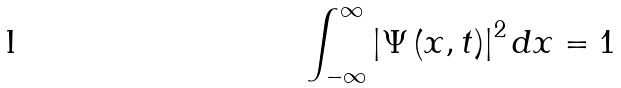Convert formula to latex. <formula><loc_0><loc_0><loc_500><loc_500>\int _ { - \infty } ^ { \infty } \left | \Psi \left ( x , t \right ) \right | ^ { 2 } d x = 1</formula> 